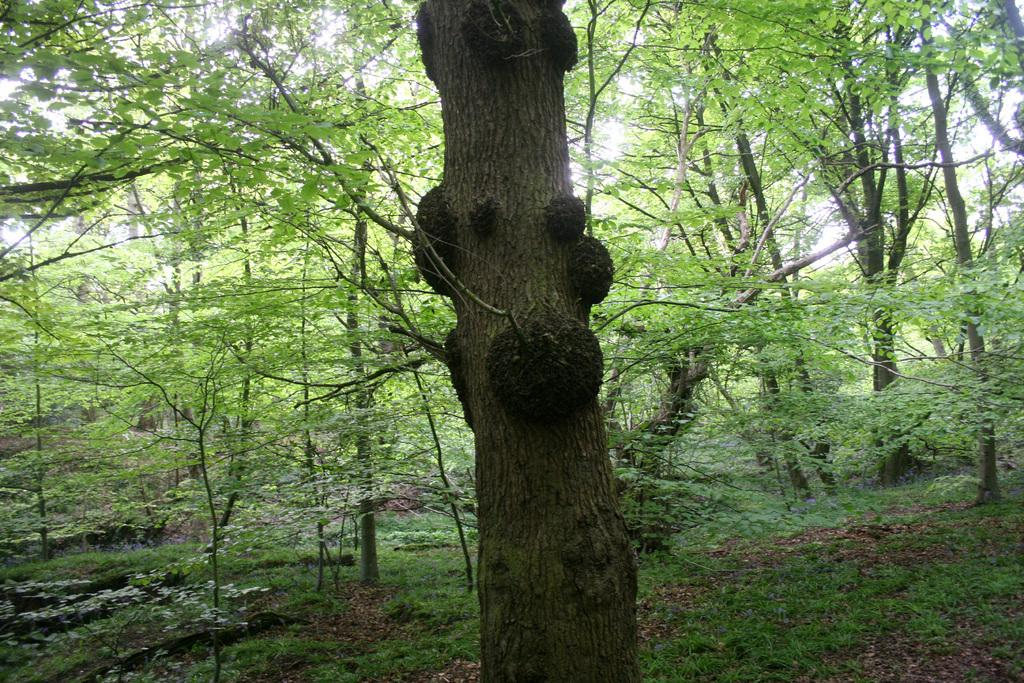What type of vegetation is present in the image? There are many trees in the image. What is covering the ground in the image? There is grass on the ground in the image. What can be seen in the background of the image? The sky is visible in the background of the image. What type of medical advice can be sought from the trees in the image? There are no doctors or medical advice present in the image; it features trees, grass, and the sky. 